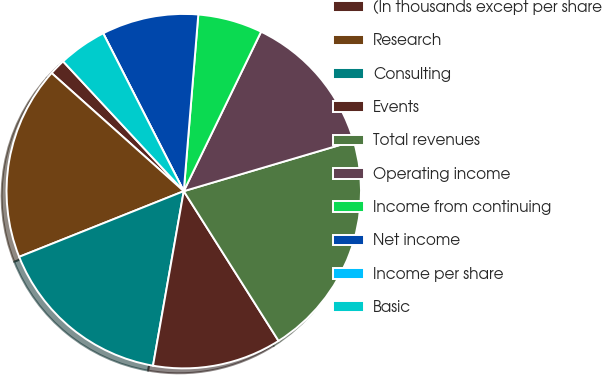<chart> <loc_0><loc_0><loc_500><loc_500><pie_chart><fcel>(In thousands except per share<fcel>Research<fcel>Consulting<fcel>Events<fcel>Total revenues<fcel>Operating income<fcel>Income from continuing<fcel>Net income<fcel>Income per share<fcel>Basic<nl><fcel>1.47%<fcel>17.65%<fcel>16.18%<fcel>11.76%<fcel>20.59%<fcel>13.24%<fcel>5.88%<fcel>8.82%<fcel>0.0%<fcel>4.41%<nl></chart> 